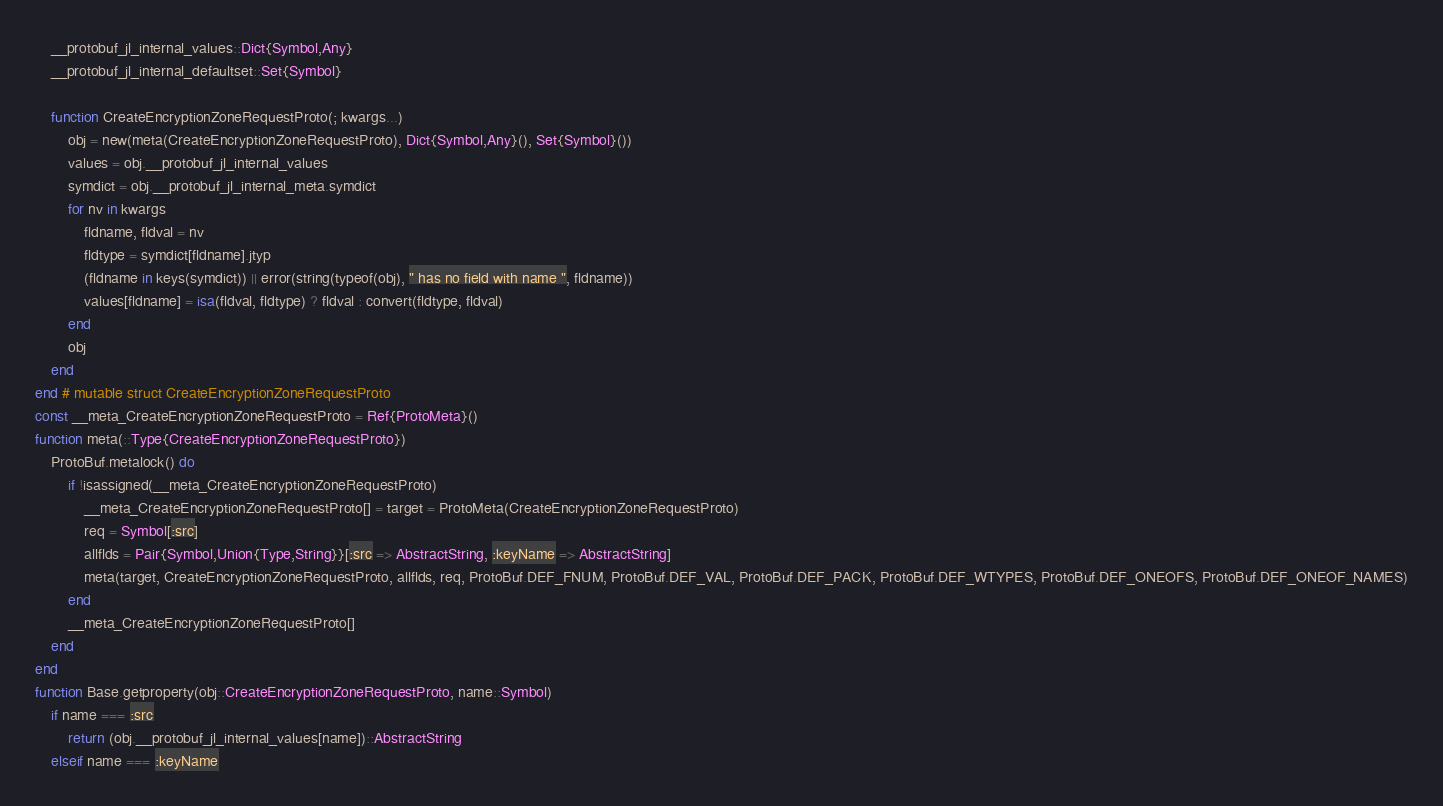<code> <loc_0><loc_0><loc_500><loc_500><_Julia_>    __protobuf_jl_internal_values::Dict{Symbol,Any}
    __protobuf_jl_internal_defaultset::Set{Symbol}

    function CreateEncryptionZoneRequestProto(; kwargs...)
        obj = new(meta(CreateEncryptionZoneRequestProto), Dict{Symbol,Any}(), Set{Symbol}())
        values = obj.__protobuf_jl_internal_values
        symdict = obj.__protobuf_jl_internal_meta.symdict
        for nv in kwargs
            fldname, fldval = nv
            fldtype = symdict[fldname].jtyp
            (fldname in keys(symdict)) || error(string(typeof(obj), " has no field with name ", fldname))
            values[fldname] = isa(fldval, fldtype) ? fldval : convert(fldtype, fldval)
        end
        obj
    end
end # mutable struct CreateEncryptionZoneRequestProto
const __meta_CreateEncryptionZoneRequestProto = Ref{ProtoMeta}()
function meta(::Type{CreateEncryptionZoneRequestProto})
    ProtoBuf.metalock() do
        if !isassigned(__meta_CreateEncryptionZoneRequestProto)
            __meta_CreateEncryptionZoneRequestProto[] = target = ProtoMeta(CreateEncryptionZoneRequestProto)
            req = Symbol[:src]
            allflds = Pair{Symbol,Union{Type,String}}[:src => AbstractString, :keyName => AbstractString]
            meta(target, CreateEncryptionZoneRequestProto, allflds, req, ProtoBuf.DEF_FNUM, ProtoBuf.DEF_VAL, ProtoBuf.DEF_PACK, ProtoBuf.DEF_WTYPES, ProtoBuf.DEF_ONEOFS, ProtoBuf.DEF_ONEOF_NAMES)
        end
        __meta_CreateEncryptionZoneRequestProto[]
    end
end
function Base.getproperty(obj::CreateEncryptionZoneRequestProto, name::Symbol)
    if name === :src
        return (obj.__protobuf_jl_internal_values[name])::AbstractString
    elseif name === :keyName</code> 